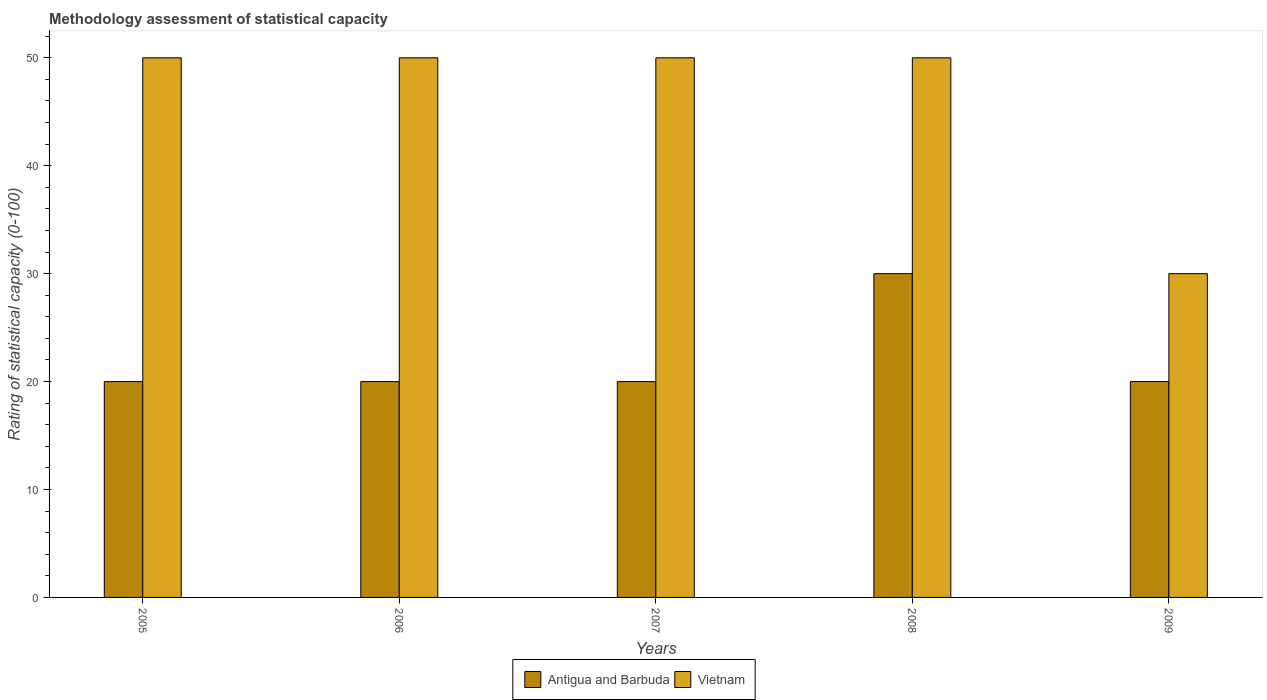How many different coloured bars are there?
Offer a very short reply. 2. Are the number of bars per tick equal to the number of legend labels?
Provide a short and direct response. Yes. Are the number of bars on each tick of the X-axis equal?
Make the answer very short. Yes. How many bars are there on the 3rd tick from the left?
Ensure brevity in your answer.  2. How many bars are there on the 2nd tick from the right?
Offer a very short reply. 2. What is the label of the 1st group of bars from the left?
Your answer should be compact. 2005. In how many cases, is the number of bars for a given year not equal to the number of legend labels?
Your answer should be very brief. 0. What is the rating of statistical capacity in Antigua and Barbuda in 2009?
Make the answer very short. 20. Across all years, what is the maximum rating of statistical capacity in Vietnam?
Provide a succinct answer. 50. Across all years, what is the minimum rating of statistical capacity in Vietnam?
Keep it short and to the point. 30. What is the total rating of statistical capacity in Vietnam in the graph?
Offer a very short reply. 230. What is the difference between the rating of statistical capacity in Vietnam in 2005 and that in 2007?
Your response must be concise. 0. What is the average rating of statistical capacity in Vietnam per year?
Offer a very short reply. 46. What is the ratio of the rating of statistical capacity in Vietnam in 2007 to that in 2009?
Give a very brief answer. 1.67. Is the rating of statistical capacity in Antigua and Barbuda in 2007 less than that in 2008?
Keep it short and to the point. Yes. What is the difference between the highest and the lowest rating of statistical capacity in Vietnam?
Provide a succinct answer. 20. Is the sum of the rating of statistical capacity in Vietnam in 2007 and 2009 greater than the maximum rating of statistical capacity in Antigua and Barbuda across all years?
Offer a very short reply. Yes. What does the 2nd bar from the left in 2005 represents?
Keep it short and to the point. Vietnam. What does the 2nd bar from the right in 2006 represents?
Keep it short and to the point. Antigua and Barbuda. How many bars are there?
Your response must be concise. 10. Are the values on the major ticks of Y-axis written in scientific E-notation?
Give a very brief answer. No. Does the graph contain any zero values?
Keep it short and to the point. No. Does the graph contain grids?
Provide a succinct answer. No. How are the legend labels stacked?
Your response must be concise. Horizontal. What is the title of the graph?
Your response must be concise. Methodology assessment of statistical capacity. What is the label or title of the X-axis?
Offer a terse response. Years. What is the label or title of the Y-axis?
Offer a very short reply. Rating of statistical capacity (0-100). What is the Rating of statistical capacity (0-100) of Vietnam in 2005?
Offer a very short reply. 50. What is the Rating of statistical capacity (0-100) of Vietnam in 2006?
Keep it short and to the point. 50. What is the Rating of statistical capacity (0-100) in Vietnam in 2007?
Your answer should be very brief. 50. What is the Rating of statistical capacity (0-100) of Antigua and Barbuda in 2008?
Provide a succinct answer. 30. What is the Rating of statistical capacity (0-100) in Antigua and Barbuda in 2009?
Keep it short and to the point. 20. Across all years, what is the minimum Rating of statistical capacity (0-100) in Antigua and Barbuda?
Make the answer very short. 20. Across all years, what is the minimum Rating of statistical capacity (0-100) of Vietnam?
Give a very brief answer. 30. What is the total Rating of statistical capacity (0-100) in Antigua and Barbuda in the graph?
Provide a succinct answer. 110. What is the total Rating of statistical capacity (0-100) in Vietnam in the graph?
Your answer should be compact. 230. What is the difference between the Rating of statistical capacity (0-100) in Vietnam in 2005 and that in 2006?
Offer a very short reply. 0. What is the difference between the Rating of statistical capacity (0-100) of Antigua and Barbuda in 2005 and that in 2007?
Provide a short and direct response. 0. What is the difference between the Rating of statistical capacity (0-100) of Antigua and Barbuda in 2005 and that in 2008?
Keep it short and to the point. -10. What is the difference between the Rating of statistical capacity (0-100) in Vietnam in 2005 and that in 2009?
Your answer should be very brief. 20. What is the difference between the Rating of statistical capacity (0-100) of Antigua and Barbuda in 2006 and that in 2007?
Your answer should be compact. 0. What is the difference between the Rating of statistical capacity (0-100) of Vietnam in 2006 and that in 2007?
Offer a terse response. 0. What is the difference between the Rating of statistical capacity (0-100) of Vietnam in 2006 and that in 2008?
Give a very brief answer. 0. What is the difference between the Rating of statistical capacity (0-100) of Antigua and Barbuda in 2006 and that in 2009?
Keep it short and to the point. 0. What is the difference between the Rating of statistical capacity (0-100) in Antigua and Barbuda in 2006 and the Rating of statistical capacity (0-100) in Vietnam in 2007?
Offer a terse response. -30. What is the difference between the Rating of statistical capacity (0-100) in Antigua and Barbuda in 2007 and the Rating of statistical capacity (0-100) in Vietnam in 2009?
Your answer should be very brief. -10. What is the average Rating of statistical capacity (0-100) in Vietnam per year?
Keep it short and to the point. 46. In the year 2005, what is the difference between the Rating of statistical capacity (0-100) of Antigua and Barbuda and Rating of statistical capacity (0-100) of Vietnam?
Your answer should be very brief. -30. In the year 2006, what is the difference between the Rating of statistical capacity (0-100) in Antigua and Barbuda and Rating of statistical capacity (0-100) in Vietnam?
Provide a short and direct response. -30. In the year 2007, what is the difference between the Rating of statistical capacity (0-100) of Antigua and Barbuda and Rating of statistical capacity (0-100) of Vietnam?
Make the answer very short. -30. In the year 2008, what is the difference between the Rating of statistical capacity (0-100) of Antigua and Barbuda and Rating of statistical capacity (0-100) of Vietnam?
Your answer should be compact. -20. In the year 2009, what is the difference between the Rating of statistical capacity (0-100) of Antigua and Barbuda and Rating of statistical capacity (0-100) of Vietnam?
Offer a very short reply. -10. What is the ratio of the Rating of statistical capacity (0-100) in Antigua and Barbuda in 2005 to that in 2007?
Offer a terse response. 1. What is the ratio of the Rating of statistical capacity (0-100) of Vietnam in 2005 to that in 2008?
Ensure brevity in your answer.  1. What is the ratio of the Rating of statistical capacity (0-100) of Antigua and Barbuda in 2005 to that in 2009?
Your answer should be very brief. 1. What is the ratio of the Rating of statistical capacity (0-100) of Vietnam in 2005 to that in 2009?
Ensure brevity in your answer.  1.67. What is the ratio of the Rating of statistical capacity (0-100) of Antigua and Barbuda in 2006 to that in 2007?
Make the answer very short. 1. What is the ratio of the Rating of statistical capacity (0-100) in Vietnam in 2006 to that in 2009?
Give a very brief answer. 1.67. What is the ratio of the Rating of statistical capacity (0-100) of Vietnam in 2007 to that in 2008?
Keep it short and to the point. 1. What is the ratio of the Rating of statistical capacity (0-100) of Vietnam in 2007 to that in 2009?
Offer a terse response. 1.67. What is the ratio of the Rating of statistical capacity (0-100) of Vietnam in 2008 to that in 2009?
Offer a terse response. 1.67. What is the difference between the highest and the second highest Rating of statistical capacity (0-100) of Antigua and Barbuda?
Your response must be concise. 10. What is the difference between the highest and the second highest Rating of statistical capacity (0-100) of Vietnam?
Offer a very short reply. 0. 